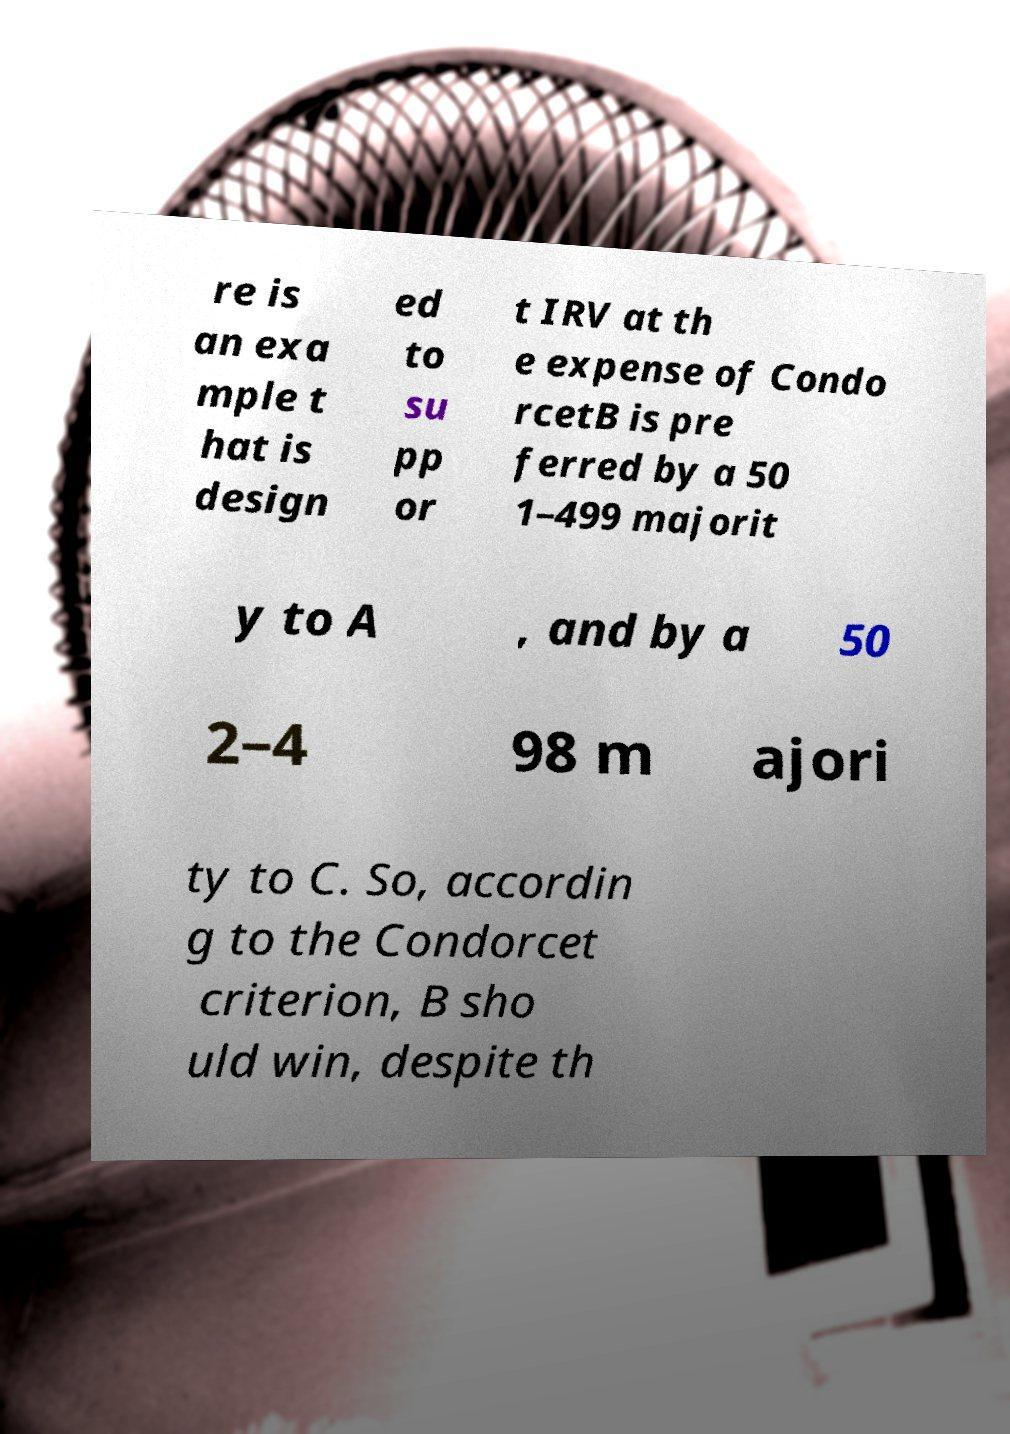Could you extract and type out the text from this image? re is an exa mple t hat is design ed to su pp or t IRV at th e expense of Condo rcetB is pre ferred by a 50 1–499 majorit y to A , and by a 50 2–4 98 m ajori ty to C. So, accordin g to the Condorcet criterion, B sho uld win, despite th 